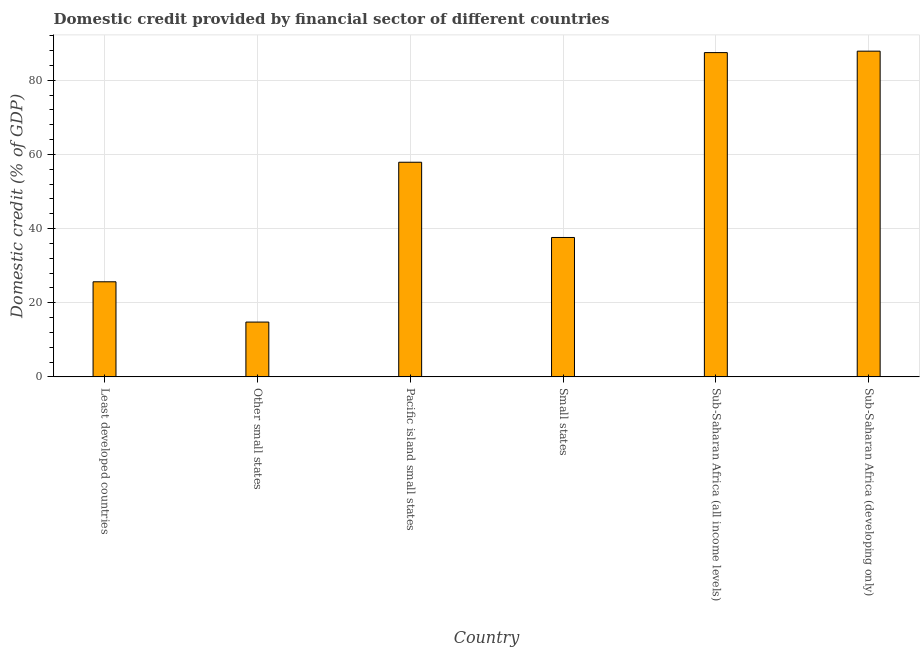Does the graph contain any zero values?
Provide a succinct answer. No. Does the graph contain grids?
Give a very brief answer. Yes. What is the title of the graph?
Make the answer very short. Domestic credit provided by financial sector of different countries. What is the label or title of the Y-axis?
Offer a very short reply. Domestic credit (% of GDP). What is the domestic credit provided by financial sector in Sub-Saharan Africa (developing only)?
Give a very brief answer. 87.84. Across all countries, what is the maximum domestic credit provided by financial sector?
Give a very brief answer. 87.84. Across all countries, what is the minimum domestic credit provided by financial sector?
Provide a short and direct response. 14.78. In which country was the domestic credit provided by financial sector maximum?
Offer a very short reply. Sub-Saharan Africa (developing only). In which country was the domestic credit provided by financial sector minimum?
Provide a short and direct response. Other small states. What is the sum of the domestic credit provided by financial sector?
Give a very brief answer. 311.2. What is the difference between the domestic credit provided by financial sector in Small states and Sub-Saharan Africa (developing only)?
Your answer should be compact. -50.25. What is the average domestic credit provided by financial sector per country?
Provide a short and direct response. 51.87. What is the median domestic credit provided by financial sector?
Provide a succinct answer. 47.74. In how many countries, is the domestic credit provided by financial sector greater than 32 %?
Your answer should be compact. 4. What is the ratio of the domestic credit provided by financial sector in Other small states to that in Pacific island small states?
Provide a short and direct response. 0.26. What is the difference between the highest and the second highest domestic credit provided by financial sector?
Keep it short and to the point. 0.39. What is the difference between the highest and the lowest domestic credit provided by financial sector?
Your answer should be very brief. 73.07. How many bars are there?
Offer a very short reply. 6. Are the values on the major ticks of Y-axis written in scientific E-notation?
Provide a short and direct response. No. What is the Domestic credit (% of GDP) in Least developed countries?
Your answer should be very brief. 25.64. What is the Domestic credit (% of GDP) in Other small states?
Your answer should be very brief. 14.78. What is the Domestic credit (% of GDP) in Pacific island small states?
Provide a short and direct response. 57.89. What is the Domestic credit (% of GDP) of Small states?
Provide a succinct answer. 37.59. What is the Domestic credit (% of GDP) of Sub-Saharan Africa (all income levels)?
Make the answer very short. 87.46. What is the Domestic credit (% of GDP) in Sub-Saharan Africa (developing only)?
Your response must be concise. 87.84. What is the difference between the Domestic credit (% of GDP) in Least developed countries and Other small states?
Your answer should be very brief. 10.86. What is the difference between the Domestic credit (% of GDP) in Least developed countries and Pacific island small states?
Your answer should be very brief. -32.24. What is the difference between the Domestic credit (% of GDP) in Least developed countries and Small states?
Keep it short and to the point. -11.95. What is the difference between the Domestic credit (% of GDP) in Least developed countries and Sub-Saharan Africa (all income levels)?
Your response must be concise. -61.81. What is the difference between the Domestic credit (% of GDP) in Least developed countries and Sub-Saharan Africa (developing only)?
Ensure brevity in your answer.  -62.2. What is the difference between the Domestic credit (% of GDP) in Other small states and Pacific island small states?
Offer a very short reply. -43.11. What is the difference between the Domestic credit (% of GDP) in Other small states and Small states?
Provide a short and direct response. -22.82. What is the difference between the Domestic credit (% of GDP) in Other small states and Sub-Saharan Africa (all income levels)?
Keep it short and to the point. -72.68. What is the difference between the Domestic credit (% of GDP) in Other small states and Sub-Saharan Africa (developing only)?
Your response must be concise. -73.07. What is the difference between the Domestic credit (% of GDP) in Pacific island small states and Small states?
Offer a terse response. 20.29. What is the difference between the Domestic credit (% of GDP) in Pacific island small states and Sub-Saharan Africa (all income levels)?
Offer a very short reply. -29.57. What is the difference between the Domestic credit (% of GDP) in Pacific island small states and Sub-Saharan Africa (developing only)?
Your answer should be compact. -29.96. What is the difference between the Domestic credit (% of GDP) in Small states and Sub-Saharan Africa (all income levels)?
Ensure brevity in your answer.  -49.86. What is the difference between the Domestic credit (% of GDP) in Small states and Sub-Saharan Africa (developing only)?
Your answer should be very brief. -50.25. What is the difference between the Domestic credit (% of GDP) in Sub-Saharan Africa (all income levels) and Sub-Saharan Africa (developing only)?
Make the answer very short. -0.39. What is the ratio of the Domestic credit (% of GDP) in Least developed countries to that in Other small states?
Make the answer very short. 1.74. What is the ratio of the Domestic credit (% of GDP) in Least developed countries to that in Pacific island small states?
Keep it short and to the point. 0.44. What is the ratio of the Domestic credit (% of GDP) in Least developed countries to that in Small states?
Provide a short and direct response. 0.68. What is the ratio of the Domestic credit (% of GDP) in Least developed countries to that in Sub-Saharan Africa (all income levels)?
Provide a short and direct response. 0.29. What is the ratio of the Domestic credit (% of GDP) in Least developed countries to that in Sub-Saharan Africa (developing only)?
Provide a short and direct response. 0.29. What is the ratio of the Domestic credit (% of GDP) in Other small states to that in Pacific island small states?
Your response must be concise. 0.26. What is the ratio of the Domestic credit (% of GDP) in Other small states to that in Small states?
Provide a succinct answer. 0.39. What is the ratio of the Domestic credit (% of GDP) in Other small states to that in Sub-Saharan Africa (all income levels)?
Provide a succinct answer. 0.17. What is the ratio of the Domestic credit (% of GDP) in Other small states to that in Sub-Saharan Africa (developing only)?
Offer a very short reply. 0.17. What is the ratio of the Domestic credit (% of GDP) in Pacific island small states to that in Small states?
Keep it short and to the point. 1.54. What is the ratio of the Domestic credit (% of GDP) in Pacific island small states to that in Sub-Saharan Africa (all income levels)?
Your answer should be compact. 0.66. What is the ratio of the Domestic credit (% of GDP) in Pacific island small states to that in Sub-Saharan Africa (developing only)?
Your answer should be compact. 0.66. What is the ratio of the Domestic credit (% of GDP) in Small states to that in Sub-Saharan Africa (all income levels)?
Your answer should be very brief. 0.43. What is the ratio of the Domestic credit (% of GDP) in Small states to that in Sub-Saharan Africa (developing only)?
Offer a terse response. 0.43. 